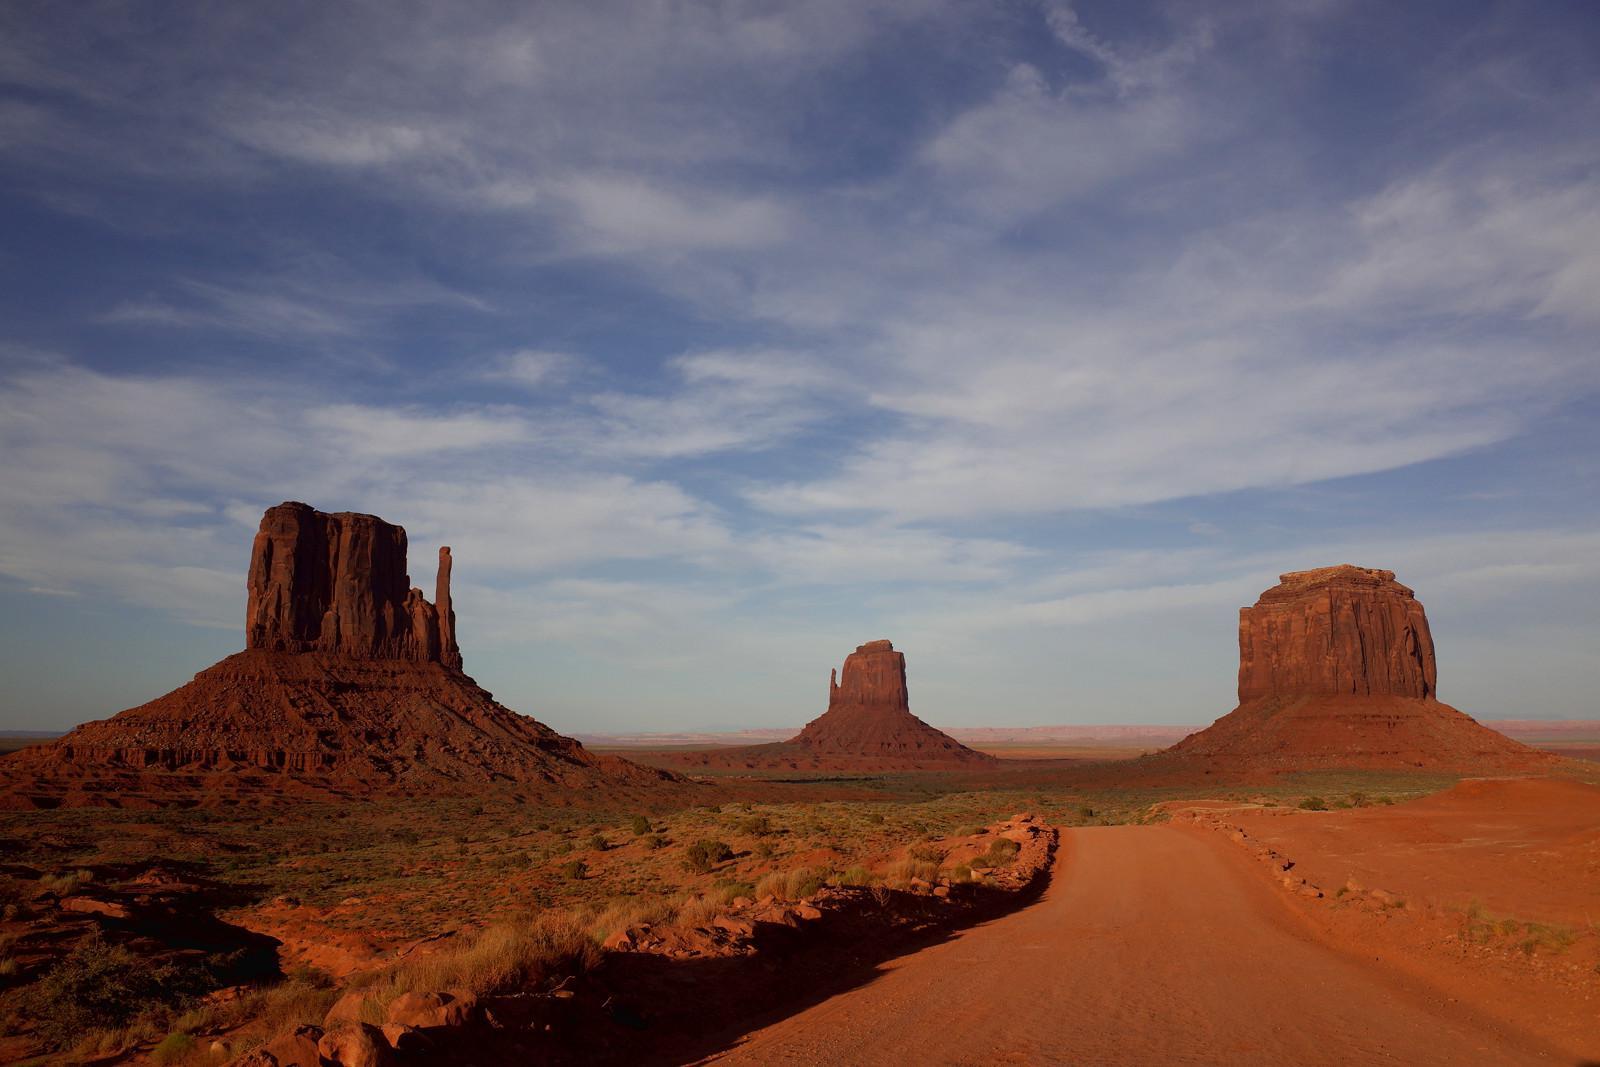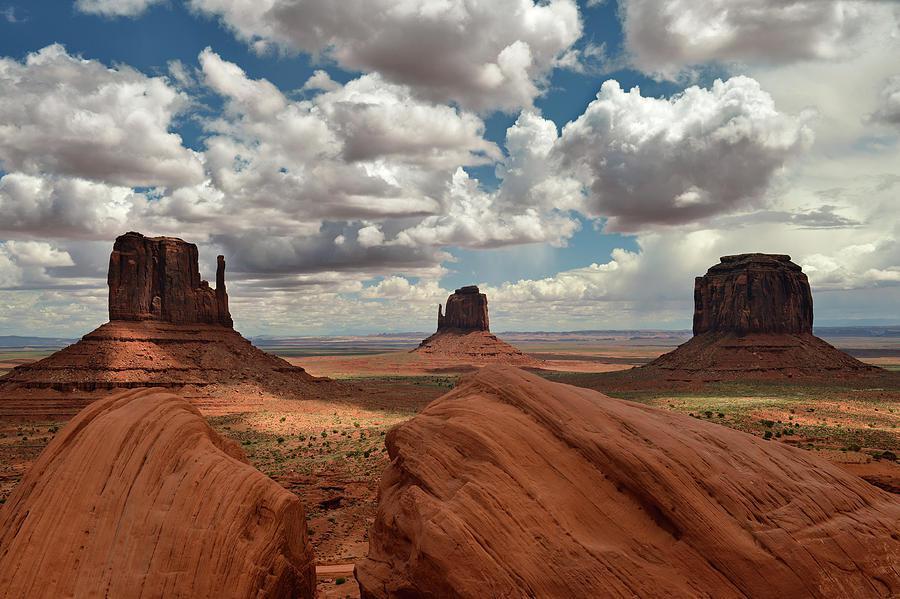The first image is the image on the left, the second image is the image on the right. Given the left and right images, does the statement "In the left image, there is an upright object in the foreground with rock formations behind." hold true? Answer yes or no. No. The first image is the image on the left, the second image is the image on the right. For the images displayed, is the sentence "The left and right images show the same view of three rock formations, but under different sky conditions." factually correct? Answer yes or no. Yes. 